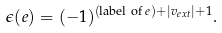Convert formula to latex. <formula><loc_0><loc_0><loc_500><loc_500>\epsilon ( e ) = ( - 1 ) ^ { ( \text {label of $e$} ) + | v _ { e x t } | + 1 } .</formula> 